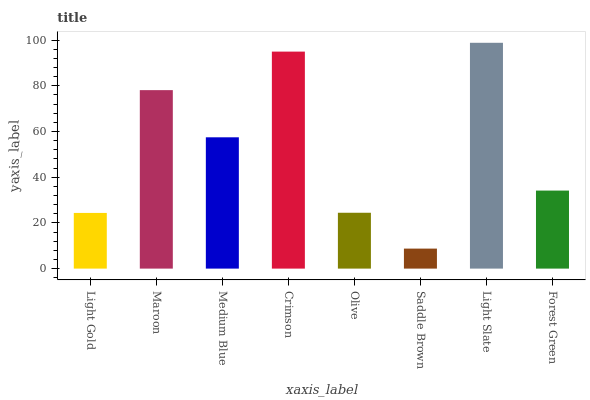Is Saddle Brown the minimum?
Answer yes or no. Yes. Is Light Slate the maximum?
Answer yes or no. Yes. Is Maroon the minimum?
Answer yes or no. No. Is Maroon the maximum?
Answer yes or no. No. Is Maroon greater than Light Gold?
Answer yes or no. Yes. Is Light Gold less than Maroon?
Answer yes or no. Yes. Is Light Gold greater than Maroon?
Answer yes or no. No. Is Maroon less than Light Gold?
Answer yes or no. No. Is Medium Blue the high median?
Answer yes or no. Yes. Is Forest Green the low median?
Answer yes or no. Yes. Is Light Slate the high median?
Answer yes or no. No. Is Light Gold the low median?
Answer yes or no. No. 